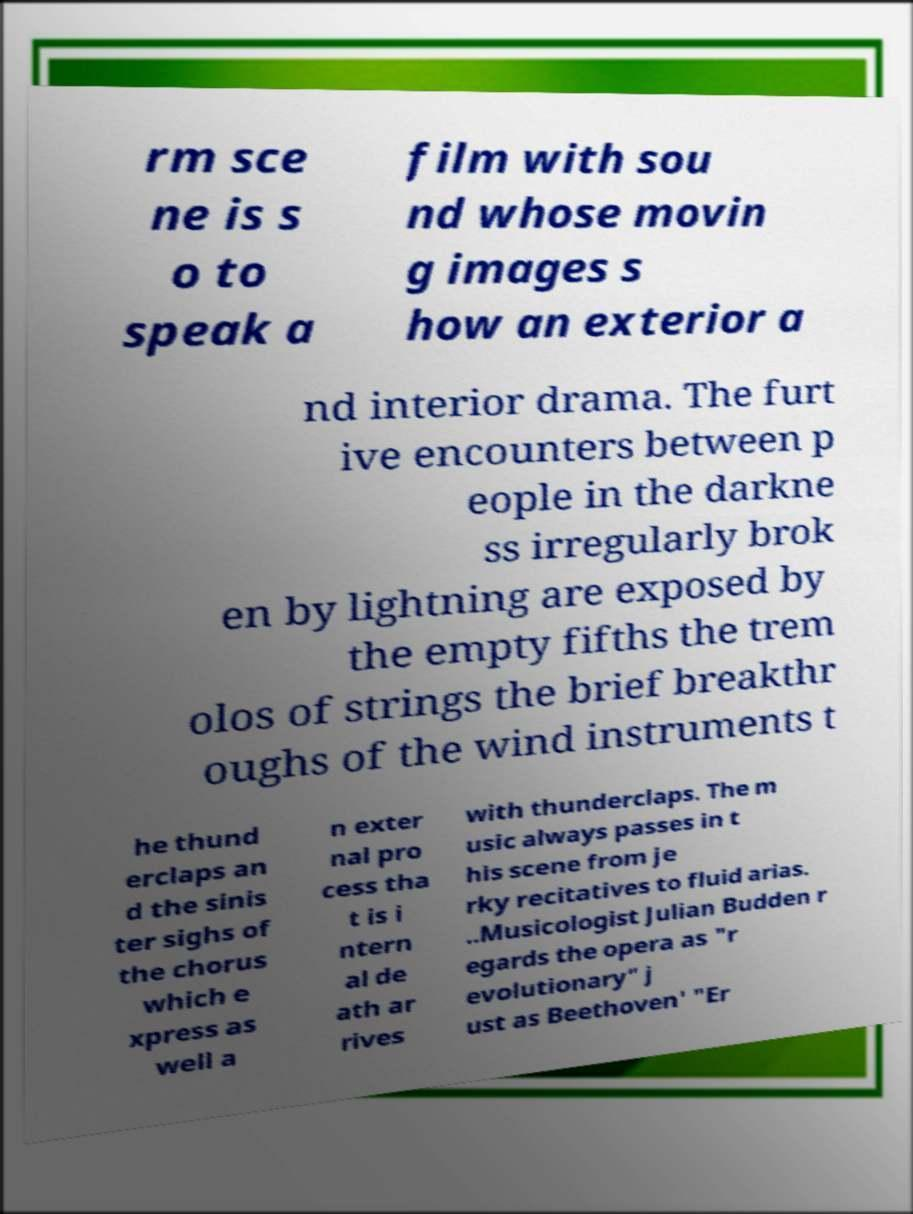There's text embedded in this image that I need extracted. Can you transcribe it verbatim? rm sce ne is s o to speak a film with sou nd whose movin g images s how an exterior a nd interior drama. The furt ive encounters between p eople in the darkne ss irregularly brok en by lightning are exposed by the empty fifths the trem olos of strings the brief breakthr oughs of the wind instruments t he thund erclaps an d the sinis ter sighs of the chorus which e xpress as well a n exter nal pro cess tha t is i ntern al de ath ar rives with thunderclaps. The m usic always passes in t his scene from je rky recitatives to fluid arias. ..Musicologist Julian Budden r egards the opera as "r evolutionary" j ust as Beethoven' "Er 